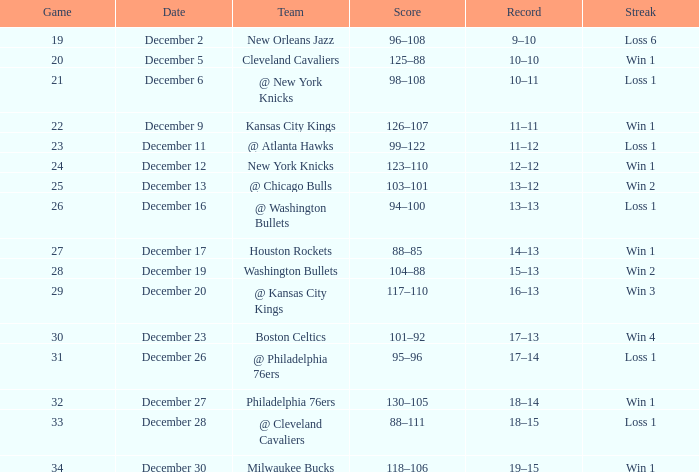What is the Score of the Game with a Record of 13–12? 103–101. 